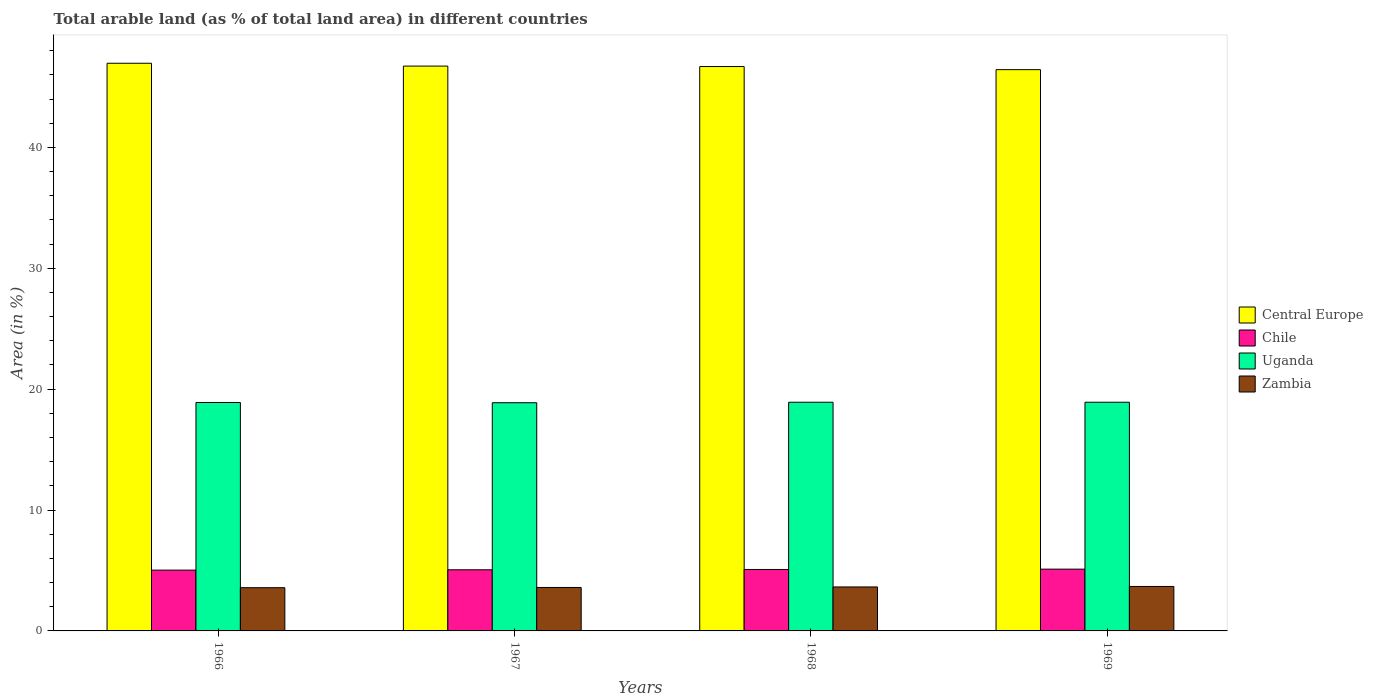How many bars are there on the 4th tick from the left?
Provide a succinct answer. 4. How many bars are there on the 3rd tick from the right?
Your response must be concise. 4. What is the label of the 1st group of bars from the left?
Keep it short and to the point. 1966. In how many cases, is the number of bars for a given year not equal to the number of legend labels?
Your answer should be compact. 0. What is the percentage of arable land in Uganda in 1969?
Provide a short and direct response. 18.92. Across all years, what is the maximum percentage of arable land in Uganda?
Your answer should be very brief. 18.92. Across all years, what is the minimum percentage of arable land in Zambia?
Give a very brief answer. 3.58. In which year was the percentage of arable land in Central Europe maximum?
Offer a terse response. 1966. In which year was the percentage of arable land in Uganda minimum?
Provide a succinct answer. 1967. What is the total percentage of arable land in Uganda in the graph?
Offer a terse response. 75.61. What is the difference between the percentage of arable land in Central Europe in 1966 and that in 1969?
Offer a terse response. 0.53. What is the difference between the percentage of arable land in Chile in 1966 and the percentage of arable land in Zambia in 1967?
Provide a short and direct response. 1.44. What is the average percentage of arable land in Central Europe per year?
Your answer should be compact. 46.7. In the year 1967, what is the difference between the percentage of arable land in Chile and percentage of arable land in Uganda?
Offer a terse response. -13.82. In how many years, is the percentage of arable land in Uganda greater than 40 %?
Keep it short and to the point. 0. What is the ratio of the percentage of arable land in Uganda in 1966 to that in 1969?
Provide a succinct answer. 1. What is the difference between the highest and the second highest percentage of arable land in Zambia?
Your answer should be compact. 0.04. What is the difference between the highest and the lowest percentage of arable land in Central Europe?
Offer a terse response. 0.53. Is the sum of the percentage of arable land in Uganda in 1968 and 1969 greater than the maximum percentage of arable land in Chile across all years?
Make the answer very short. Yes. What does the 2nd bar from the left in 1967 represents?
Your answer should be compact. Chile. What does the 2nd bar from the right in 1968 represents?
Your answer should be compact. Uganda. Is it the case that in every year, the sum of the percentage of arable land in Central Europe and percentage of arable land in Zambia is greater than the percentage of arable land in Uganda?
Your answer should be compact. Yes. How many bars are there?
Make the answer very short. 16. Are all the bars in the graph horizontal?
Ensure brevity in your answer.  No. What is the difference between two consecutive major ticks on the Y-axis?
Keep it short and to the point. 10. Where does the legend appear in the graph?
Your response must be concise. Center right. How many legend labels are there?
Keep it short and to the point. 4. How are the legend labels stacked?
Provide a short and direct response. Vertical. What is the title of the graph?
Your answer should be compact. Total arable land (as % of total land area) in different countries. What is the label or title of the X-axis?
Make the answer very short. Years. What is the label or title of the Y-axis?
Your answer should be compact. Area (in %). What is the Area (in %) of Central Europe in 1966?
Make the answer very short. 46.96. What is the Area (in %) of Chile in 1966?
Give a very brief answer. 5.03. What is the Area (in %) of Uganda in 1966?
Ensure brevity in your answer.  18.9. What is the Area (in %) in Zambia in 1966?
Make the answer very short. 3.58. What is the Area (in %) of Central Europe in 1967?
Offer a very short reply. 46.73. What is the Area (in %) in Chile in 1967?
Offer a very short reply. 5.06. What is the Area (in %) of Uganda in 1967?
Keep it short and to the point. 18.88. What is the Area (in %) of Zambia in 1967?
Your answer should be very brief. 3.59. What is the Area (in %) in Central Europe in 1968?
Your answer should be very brief. 46.69. What is the Area (in %) of Chile in 1968?
Your response must be concise. 5.08. What is the Area (in %) of Uganda in 1968?
Give a very brief answer. 18.92. What is the Area (in %) of Zambia in 1968?
Provide a succinct answer. 3.64. What is the Area (in %) in Central Europe in 1969?
Provide a succinct answer. 46.43. What is the Area (in %) in Chile in 1969?
Provide a short and direct response. 5.11. What is the Area (in %) in Uganda in 1969?
Make the answer very short. 18.92. What is the Area (in %) in Zambia in 1969?
Ensure brevity in your answer.  3.68. Across all years, what is the maximum Area (in %) in Central Europe?
Offer a very short reply. 46.96. Across all years, what is the maximum Area (in %) in Chile?
Keep it short and to the point. 5.11. Across all years, what is the maximum Area (in %) in Uganda?
Provide a succinct answer. 18.92. Across all years, what is the maximum Area (in %) of Zambia?
Provide a succinct answer. 3.68. Across all years, what is the minimum Area (in %) in Central Europe?
Give a very brief answer. 46.43. Across all years, what is the minimum Area (in %) of Chile?
Provide a short and direct response. 5.03. Across all years, what is the minimum Area (in %) of Uganda?
Offer a terse response. 18.88. Across all years, what is the minimum Area (in %) in Zambia?
Your answer should be very brief. 3.58. What is the total Area (in %) of Central Europe in the graph?
Ensure brevity in your answer.  186.82. What is the total Area (in %) in Chile in the graph?
Provide a short and direct response. 20.28. What is the total Area (in %) of Uganda in the graph?
Make the answer very short. 75.61. What is the total Area (in %) in Zambia in the graph?
Provide a short and direct response. 14.49. What is the difference between the Area (in %) of Central Europe in 1966 and that in 1967?
Make the answer very short. 0.23. What is the difference between the Area (in %) in Chile in 1966 and that in 1967?
Provide a short and direct response. -0.03. What is the difference between the Area (in %) in Zambia in 1966 and that in 1967?
Your answer should be very brief. -0.02. What is the difference between the Area (in %) of Central Europe in 1966 and that in 1968?
Your response must be concise. 0.27. What is the difference between the Area (in %) of Chile in 1966 and that in 1968?
Make the answer very short. -0.05. What is the difference between the Area (in %) of Uganda in 1966 and that in 1968?
Your answer should be compact. -0.02. What is the difference between the Area (in %) in Zambia in 1966 and that in 1968?
Give a very brief answer. -0.06. What is the difference between the Area (in %) of Central Europe in 1966 and that in 1969?
Provide a short and direct response. 0.53. What is the difference between the Area (in %) in Chile in 1966 and that in 1969?
Offer a terse response. -0.08. What is the difference between the Area (in %) of Uganda in 1966 and that in 1969?
Keep it short and to the point. -0.02. What is the difference between the Area (in %) of Zambia in 1966 and that in 1969?
Your answer should be very brief. -0.1. What is the difference between the Area (in %) in Central Europe in 1967 and that in 1968?
Keep it short and to the point. 0.04. What is the difference between the Area (in %) in Chile in 1967 and that in 1968?
Your answer should be compact. -0.03. What is the difference between the Area (in %) in Uganda in 1967 and that in 1968?
Your answer should be compact. -0.04. What is the difference between the Area (in %) of Zambia in 1967 and that in 1968?
Give a very brief answer. -0.04. What is the difference between the Area (in %) in Central Europe in 1967 and that in 1969?
Your answer should be compact. 0.3. What is the difference between the Area (in %) of Chile in 1967 and that in 1969?
Keep it short and to the point. -0.05. What is the difference between the Area (in %) in Uganda in 1967 and that in 1969?
Provide a short and direct response. -0.04. What is the difference between the Area (in %) of Zambia in 1967 and that in 1969?
Your answer should be very brief. -0.08. What is the difference between the Area (in %) in Central Europe in 1968 and that in 1969?
Your answer should be compact. 0.26. What is the difference between the Area (in %) in Chile in 1968 and that in 1969?
Offer a very short reply. -0.03. What is the difference between the Area (in %) in Zambia in 1968 and that in 1969?
Keep it short and to the point. -0.04. What is the difference between the Area (in %) of Central Europe in 1966 and the Area (in %) of Chile in 1967?
Your answer should be very brief. 41.91. What is the difference between the Area (in %) of Central Europe in 1966 and the Area (in %) of Uganda in 1967?
Your response must be concise. 28.08. What is the difference between the Area (in %) of Central Europe in 1966 and the Area (in %) of Zambia in 1967?
Your response must be concise. 43.37. What is the difference between the Area (in %) in Chile in 1966 and the Area (in %) in Uganda in 1967?
Make the answer very short. -13.85. What is the difference between the Area (in %) in Chile in 1966 and the Area (in %) in Zambia in 1967?
Offer a very short reply. 1.44. What is the difference between the Area (in %) of Uganda in 1966 and the Area (in %) of Zambia in 1967?
Offer a terse response. 15.3. What is the difference between the Area (in %) in Central Europe in 1966 and the Area (in %) in Chile in 1968?
Provide a short and direct response. 41.88. What is the difference between the Area (in %) in Central Europe in 1966 and the Area (in %) in Uganda in 1968?
Ensure brevity in your answer.  28.04. What is the difference between the Area (in %) in Central Europe in 1966 and the Area (in %) in Zambia in 1968?
Your answer should be very brief. 43.32. What is the difference between the Area (in %) in Chile in 1966 and the Area (in %) in Uganda in 1968?
Your response must be concise. -13.89. What is the difference between the Area (in %) in Chile in 1966 and the Area (in %) in Zambia in 1968?
Keep it short and to the point. 1.39. What is the difference between the Area (in %) in Uganda in 1966 and the Area (in %) in Zambia in 1968?
Your response must be concise. 15.26. What is the difference between the Area (in %) of Central Europe in 1966 and the Area (in %) of Chile in 1969?
Your response must be concise. 41.85. What is the difference between the Area (in %) in Central Europe in 1966 and the Area (in %) in Uganda in 1969?
Offer a terse response. 28.04. What is the difference between the Area (in %) of Central Europe in 1966 and the Area (in %) of Zambia in 1969?
Give a very brief answer. 43.28. What is the difference between the Area (in %) of Chile in 1966 and the Area (in %) of Uganda in 1969?
Your answer should be compact. -13.89. What is the difference between the Area (in %) of Chile in 1966 and the Area (in %) of Zambia in 1969?
Keep it short and to the point. 1.35. What is the difference between the Area (in %) of Uganda in 1966 and the Area (in %) of Zambia in 1969?
Your answer should be very brief. 15.22. What is the difference between the Area (in %) in Central Europe in 1967 and the Area (in %) in Chile in 1968?
Offer a terse response. 41.64. What is the difference between the Area (in %) in Central Europe in 1967 and the Area (in %) in Uganda in 1968?
Keep it short and to the point. 27.81. What is the difference between the Area (in %) in Central Europe in 1967 and the Area (in %) in Zambia in 1968?
Your answer should be compact. 43.09. What is the difference between the Area (in %) of Chile in 1967 and the Area (in %) of Uganda in 1968?
Offer a terse response. -13.86. What is the difference between the Area (in %) in Chile in 1967 and the Area (in %) in Zambia in 1968?
Provide a succinct answer. 1.42. What is the difference between the Area (in %) in Uganda in 1967 and the Area (in %) in Zambia in 1968?
Your response must be concise. 15.24. What is the difference between the Area (in %) of Central Europe in 1967 and the Area (in %) of Chile in 1969?
Keep it short and to the point. 41.62. What is the difference between the Area (in %) in Central Europe in 1967 and the Area (in %) in Uganda in 1969?
Offer a terse response. 27.81. What is the difference between the Area (in %) in Central Europe in 1967 and the Area (in %) in Zambia in 1969?
Your answer should be compact. 43.05. What is the difference between the Area (in %) in Chile in 1967 and the Area (in %) in Uganda in 1969?
Ensure brevity in your answer.  -13.86. What is the difference between the Area (in %) of Chile in 1967 and the Area (in %) of Zambia in 1969?
Offer a very short reply. 1.38. What is the difference between the Area (in %) in Uganda in 1967 and the Area (in %) in Zambia in 1969?
Offer a terse response. 15.2. What is the difference between the Area (in %) of Central Europe in 1968 and the Area (in %) of Chile in 1969?
Give a very brief answer. 41.58. What is the difference between the Area (in %) of Central Europe in 1968 and the Area (in %) of Uganda in 1969?
Ensure brevity in your answer.  27.77. What is the difference between the Area (in %) of Central Europe in 1968 and the Area (in %) of Zambia in 1969?
Give a very brief answer. 43.01. What is the difference between the Area (in %) in Chile in 1968 and the Area (in %) in Uganda in 1969?
Ensure brevity in your answer.  -13.83. What is the difference between the Area (in %) of Chile in 1968 and the Area (in %) of Zambia in 1969?
Provide a succinct answer. 1.41. What is the difference between the Area (in %) in Uganda in 1968 and the Area (in %) in Zambia in 1969?
Offer a very short reply. 15.24. What is the average Area (in %) of Central Europe per year?
Your answer should be compact. 46.7. What is the average Area (in %) of Chile per year?
Offer a terse response. 5.07. What is the average Area (in %) in Uganda per year?
Keep it short and to the point. 18.9. What is the average Area (in %) in Zambia per year?
Provide a succinct answer. 3.62. In the year 1966, what is the difference between the Area (in %) of Central Europe and Area (in %) of Chile?
Your response must be concise. 41.93. In the year 1966, what is the difference between the Area (in %) in Central Europe and Area (in %) in Uganda?
Give a very brief answer. 28.06. In the year 1966, what is the difference between the Area (in %) in Central Europe and Area (in %) in Zambia?
Your answer should be compact. 43.39. In the year 1966, what is the difference between the Area (in %) of Chile and Area (in %) of Uganda?
Make the answer very short. -13.87. In the year 1966, what is the difference between the Area (in %) in Chile and Area (in %) in Zambia?
Give a very brief answer. 1.45. In the year 1966, what is the difference between the Area (in %) in Uganda and Area (in %) in Zambia?
Make the answer very short. 15.32. In the year 1967, what is the difference between the Area (in %) of Central Europe and Area (in %) of Chile?
Provide a short and direct response. 41.67. In the year 1967, what is the difference between the Area (in %) of Central Europe and Area (in %) of Uganda?
Offer a very short reply. 27.85. In the year 1967, what is the difference between the Area (in %) of Central Europe and Area (in %) of Zambia?
Your response must be concise. 43.13. In the year 1967, what is the difference between the Area (in %) of Chile and Area (in %) of Uganda?
Keep it short and to the point. -13.82. In the year 1967, what is the difference between the Area (in %) of Chile and Area (in %) of Zambia?
Make the answer very short. 1.46. In the year 1967, what is the difference between the Area (in %) in Uganda and Area (in %) in Zambia?
Provide a succinct answer. 15.28. In the year 1968, what is the difference between the Area (in %) in Central Europe and Area (in %) in Chile?
Provide a short and direct response. 41.61. In the year 1968, what is the difference between the Area (in %) in Central Europe and Area (in %) in Uganda?
Provide a succinct answer. 27.77. In the year 1968, what is the difference between the Area (in %) in Central Europe and Area (in %) in Zambia?
Provide a succinct answer. 43.05. In the year 1968, what is the difference between the Area (in %) of Chile and Area (in %) of Uganda?
Offer a very short reply. -13.83. In the year 1968, what is the difference between the Area (in %) in Chile and Area (in %) in Zambia?
Give a very brief answer. 1.45. In the year 1968, what is the difference between the Area (in %) of Uganda and Area (in %) of Zambia?
Give a very brief answer. 15.28. In the year 1969, what is the difference between the Area (in %) in Central Europe and Area (in %) in Chile?
Keep it short and to the point. 41.32. In the year 1969, what is the difference between the Area (in %) in Central Europe and Area (in %) in Uganda?
Provide a succinct answer. 27.52. In the year 1969, what is the difference between the Area (in %) of Central Europe and Area (in %) of Zambia?
Your answer should be very brief. 42.76. In the year 1969, what is the difference between the Area (in %) of Chile and Area (in %) of Uganda?
Give a very brief answer. -13.81. In the year 1969, what is the difference between the Area (in %) in Chile and Area (in %) in Zambia?
Make the answer very short. 1.43. In the year 1969, what is the difference between the Area (in %) of Uganda and Area (in %) of Zambia?
Your answer should be very brief. 15.24. What is the ratio of the Area (in %) of Chile in 1966 to that in 1967?
Keep it short and to the point. 0.99. What is the ratio of the Area (in %) in Zambia in 1966 to that in 1967?
Your response must be concise. 0.99. What is the ratio of the Area (in %) of Uganda in 1966 to that in 1968?
Provide a succinct answer. 1. What is the ratio of the Area (in %) of Zambia in 1966 to that in 1968?
Make the answer very short. 0.98. What is the ratio of the Area (in %) of Central Europe in 1966 to that in 1969?
Your answer should be very brief. 1.01. What is the ratio of the Area (in %) in Chile in 1966 to that in 1969?
Provide a succinct answer. 0.98. What is the ratio of the Area (in %) in Uganda in 1966 to that in 1969?
Keep it short and to the point. 1. What is the ratio of the Area (in %) in Zambia in 1966 to that in 1969?
Ensure brevity in your answer.  0.97. What is the ratio of the Area (in %) of Central Europe in 1967 to that in 1968?
Keep it short and to the point. 1. What is the ratio of the Area (in %) in Chile in 1967 to that in 1968?
Make the answer very short. 0.99. What is the ratio of the Area (in %) of Uganda in 1967 to that in 1968?
Keep it short and to the point. 1. What is the ratio of the Area (in %) of Central Europe in 1967 to that in 1969?
Ensure brevity in your answer.  1.01. What is the ratio of the Area (in %) of Chile in 1967 to that in 1969?
Your answer should be very brief. 0.99. What is the ratio of the Area (in %) in Uganda in 1967 to that in 1969?
Your answer should be very brief. 1. What is the ratio of the Area (in %) in Zambia in 1967 to that in 1969?
Your answer should be very brief. 0.98. What is the ratio of the Area (in %) in Central Europe in 1968 to that in 1969?
Your response must be concise. 1.01. What is the ratio of the Area (in %) of Chile in 1968 to that in 1969?
Provide a short and direct response. 0.99. What is the ratio of the Area (in %) of Zambia in 1968 to that in 1969?
Offer a terse response. 0.99. What is the difference between the highest and the second highest Area (in %) in Central Europe?
Your answer should be compact. 0.23. What is the difference between the highest and the second highest Area (in %) of Chile?
Provide a succinct answer. 0.03. What is the difference between the highest and the second highest Area (in %) in Zambia?
Make the answer very short. 0.04. What is the difference between the highest and the lowest Area (in %) of Central Europe?
Make the answer very short. 0.53. What is the difference between the highest and the lowest Area (in %) of Chile?
Make the answer very short. 0.08. What is the difference between the highest and the lowest Area (in %) of Uganda?
Your response must be concise. 0.04. What is the difference between the highest and the lowest Area (in %) of Zambia?
Ensure brevity in your answer.  0.1. 